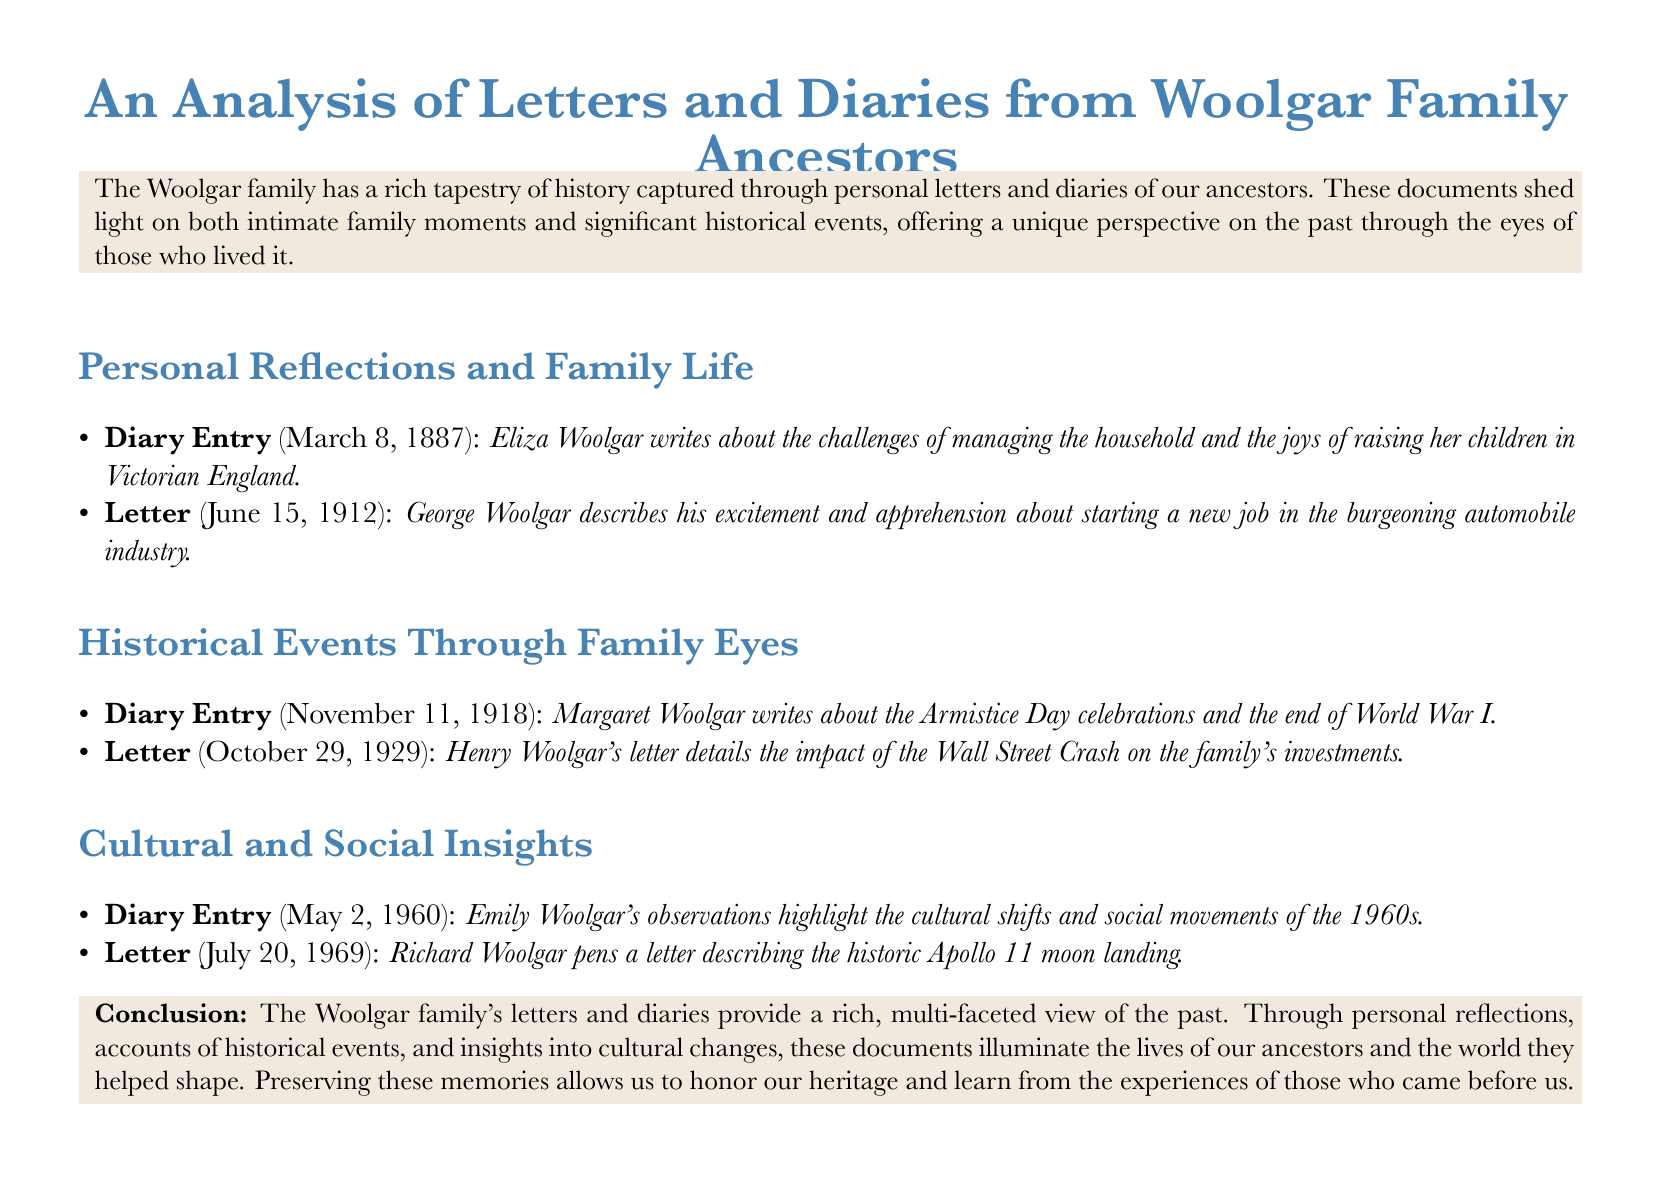What date did Eliza Woolgar write her diary entry? The diary entry by Eliza Woolgar is dated March 8, 1887.
Answer: March 8, 1887 What major historical event is described in Margaret Woolgar's diary entry? The diary entry mentions the Armistice Day celebrations, marking the end of World War I.
Answer: Armistice Day celebrations Who wrote a letter about the Apollo 11 moon landing? Richard Woolgar penned the letter describing the historic event.
Answer: Richard Woolgar What was the main topic of Henry Woolgar's letter dated October 29, 1929? The letter details the impact of the Wall Street Crash on the family's investments.
Answer: Wall Street Crash What year did Emily Woolgar make observations about the cultural shifts of the 1960s? Emily Woolgar made her observations in the year 1960.
Answer: 1960 How did George Woolgar feel about his new job? He described his excitement and apprehension regarding the new job.
Answer: Excitement and apprehension What section of the document outlines personal reflections? The section titled "Personal Reflections and Family Life" includes personal tales.
Answer: Personal Reflections and Family Life What is the primary purpose of the letters and diaries analyzed in this document? The purpose is to provide a rich, multi-faceted view of the past and honor heritage.
Answer: To provide a rich, multi-faceted view of the past 